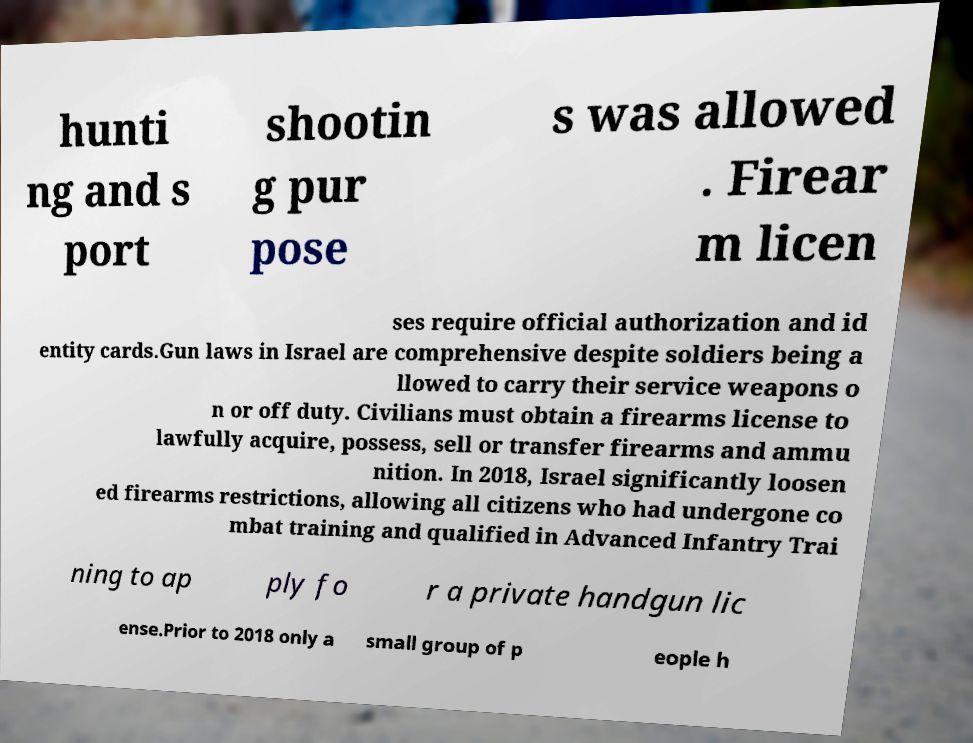For documentation purposes, I need the text within this image transcribed. Could you provide that? hunti ng and s port shootin g pur pose s was allowed . Firear m licen ses require official authorization and id entity cards.Gun laws in Israel are comprehensive despite soldiers being a llowed to carry their service weapons o n or off duty. Civilians must obtain a firearms license to lawfully acquire, possess, sell or transfer firearms and ammu nition. In 2018, Israel significantly loosen ed firearms restrictions, allowing all citizens who had undergone co mbat training and qualified in Advanced Infantry Trai ning to ap ply fo r a private handgun lic ense.Prior to 2018 only a small group of p eople h 